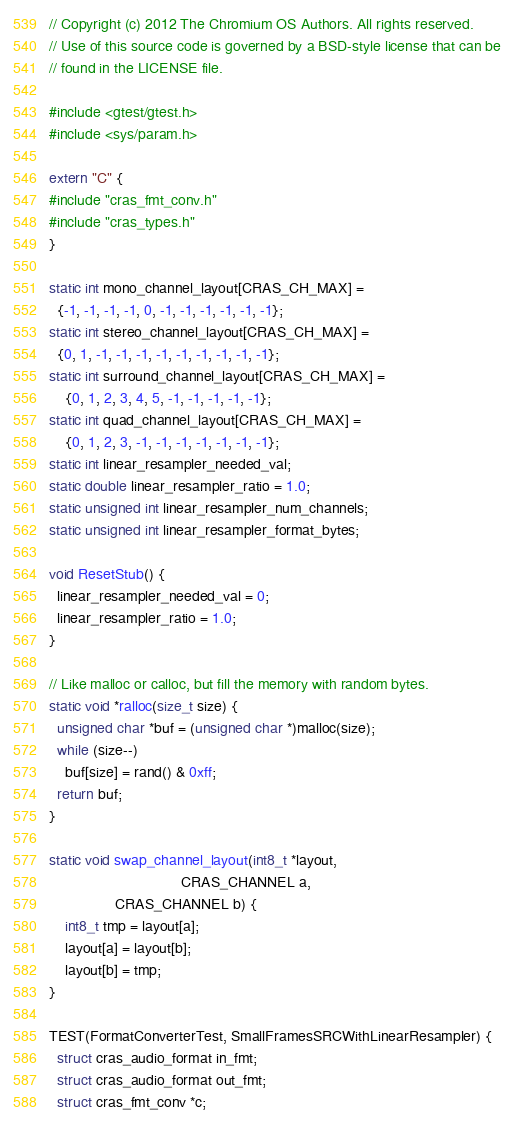Convert code to text. <code><loc_0><loc_0><loc_500><loc_500><_C++_>// Copyright (c) 2012 The Chromium OS Authors. All rights reserved.
// Use of this source code is governed by a BSD-style license that can be
// found in the LICENSE file.

#include <gtest/gtest.h>
#include <sys/param.h>

extern "C" {
#include "cras_fmt_conv.h"
#include "cras_types.h"
}

static int mono_channel_layout[CRAS_CH_MAX] =
  {-1, -1, -1, -1, 0, -1, -1, -1, -1, -1, -1};
static int stereo_channel_layout[CRAS_CH_MAX] =
  {0, 1, -1, -1, -1, -1, -1, -1, -1, -1, -1};
static int surround_channel_layout[CRAS_CH_MAX] =
	{0, 1, 2, 3, 4, 5, -1, -1, -1, -1, -1};
static int quad_channel_layout[CRAS_CH_MAX] =
	{0, 1, 2, 3, -1, -1, -1, -1, -1, -1, -1};
static int linear_resampler_needed_val;
static double linear_resampler_ratio = 1.0;
static unsigned int linear_resampler_num_channels;
static unsigned int linear_resampler_format_bytes;

void ResetStub() {
  linear_resampler_needed_val = 0;
  linear_resampler_ratio = 1.0;
}

// Like malloc or calloc, but fill the memory with random bytes.
static void *ralloc(size_t size) {
  unsigned char *buf = (unsigned char *)malloc(size);
  while (size--)
    buf[size] = rand() & 0xff;
  return buf;
}

static void swap_channel_layout(int8_t *layout,
                                CRAS_CHANNEL a,
				CRAS_CHANNEL b) {
	int8_t tmp = layout[a];
	layout[a] = layout[b];
	layout[b] = tmp;
}

TEST(FormatConverterTest, SmallFramesSRCWithLinearResampler) {
  struct cras_audio_format in_fmt;
  struct cras_audio_format out_fmt;
  struct cras_fmt_conv *c;</code> 